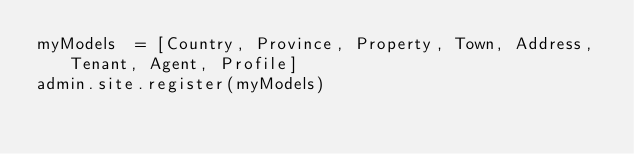<code> <loc_0><loc_0><loc_500><loc_500><_Python_>myModels  = [Country, Province, Property, Town, Address, Tenant, Agent, Profile]
admin.site.register(myModels)</code> 